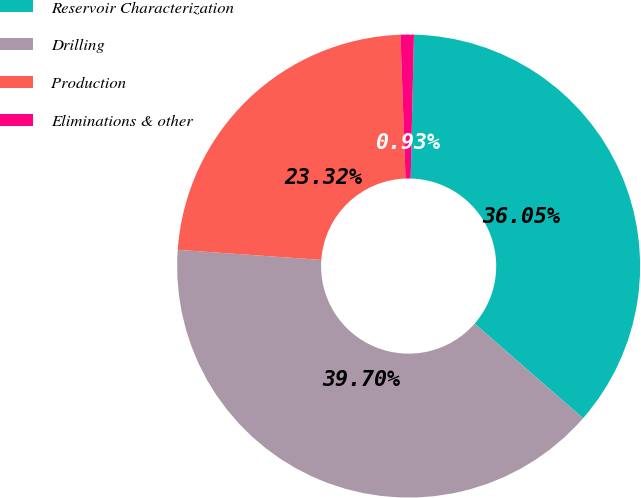Convert chart to OTSL. <chart><loc_0><loc_0><loc_500><loc_500><pie_chart><fcel>Reservoir Characterization<fcel>Drilling<fcel>Production<fcel>Eliminations & other<nl><fcel>36.05%<fcel>39.7%<fcel>23.32%<fcel>0.93%<nl></chart> 